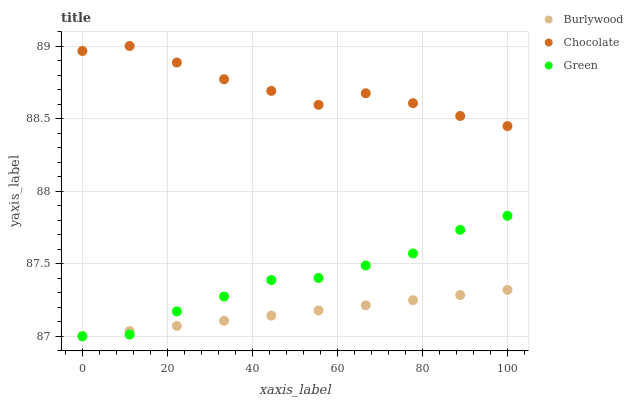Does Burlywood have the minimum area under the curve?
Answer yes or no. Yes. Does Chocolate have the maximum area under the curve?
Answer yes or no. Yes. Does Green have the minimum area under the curve?
Answer yes or no. No. Does Green have the maximum area under the curve?
Answer yes or no. No. Is Burlywood the smoothest?
Answer yes or no. Yes. Is Chocolate the roughest?
Answer yes or no. Yes. Is Green the smoothest?
Answer yes or no. No. Is Green the roughest?
Answer yes or no. No. Does Burlywood have the lowest value?
Answer yes or no. Yes. Does Chocolate have the lowest value?
Answer yes or no. No. Does Chocolate have the highest value?
Answer yes or no. Yes. Does Green have the highest value?
Answer yes or no. No. Is Burlywood less than Chocolate?
Answer yes or no. Yes. Is Chocolate greater than Green?
Answer yes or no. Yes. Does Green intersect Burlywood?
Answer yes or no. Yes. Is Green less than Burlywood?
Answer yes or no. No. Is Green greater than Burlywood?
Answer yes or no. No. Does Burlywood intersect Chocolate?
Answer yes or no. No. 